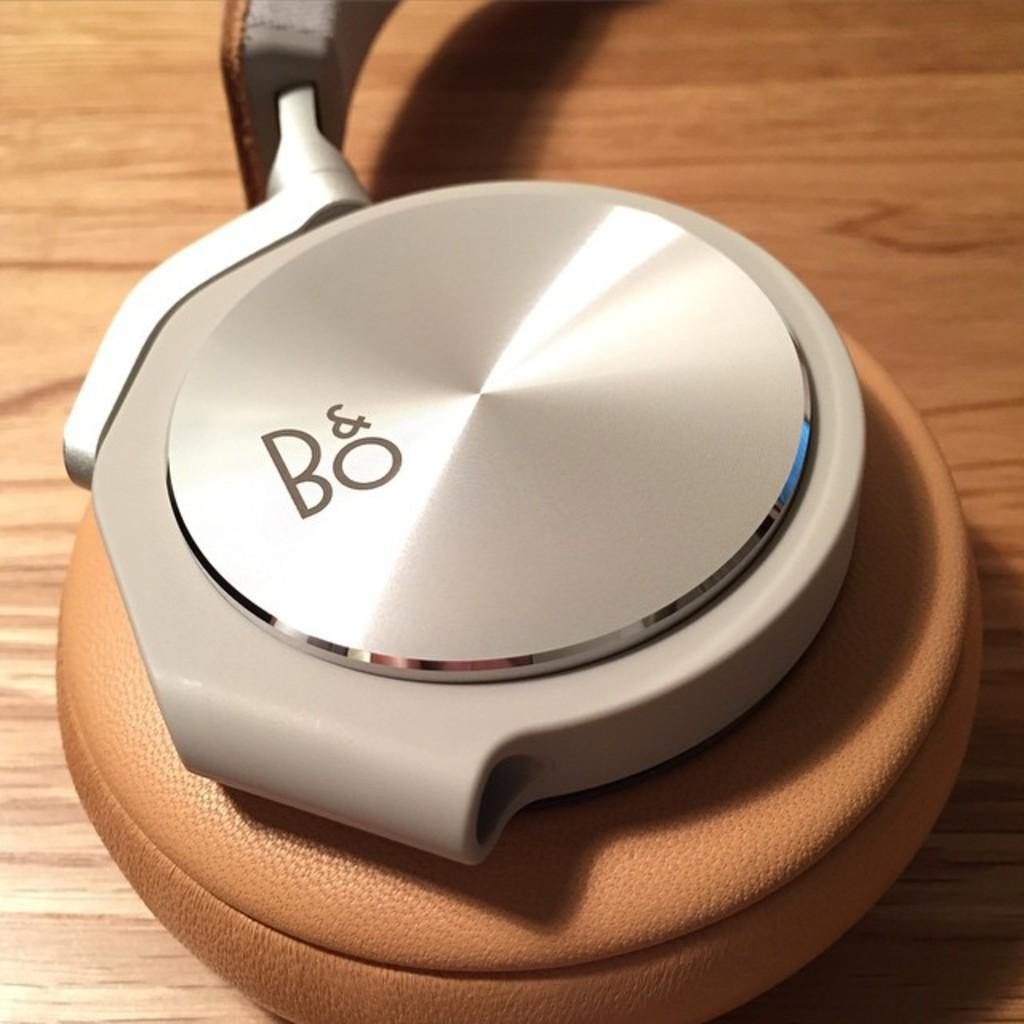<image>
Write a terse but informative summary of the picture. A silver circle has Bo in grey letters  on the top. 